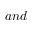<formula> <loc_0><loc_0><loc_500><loc_500>a n d</formula> 